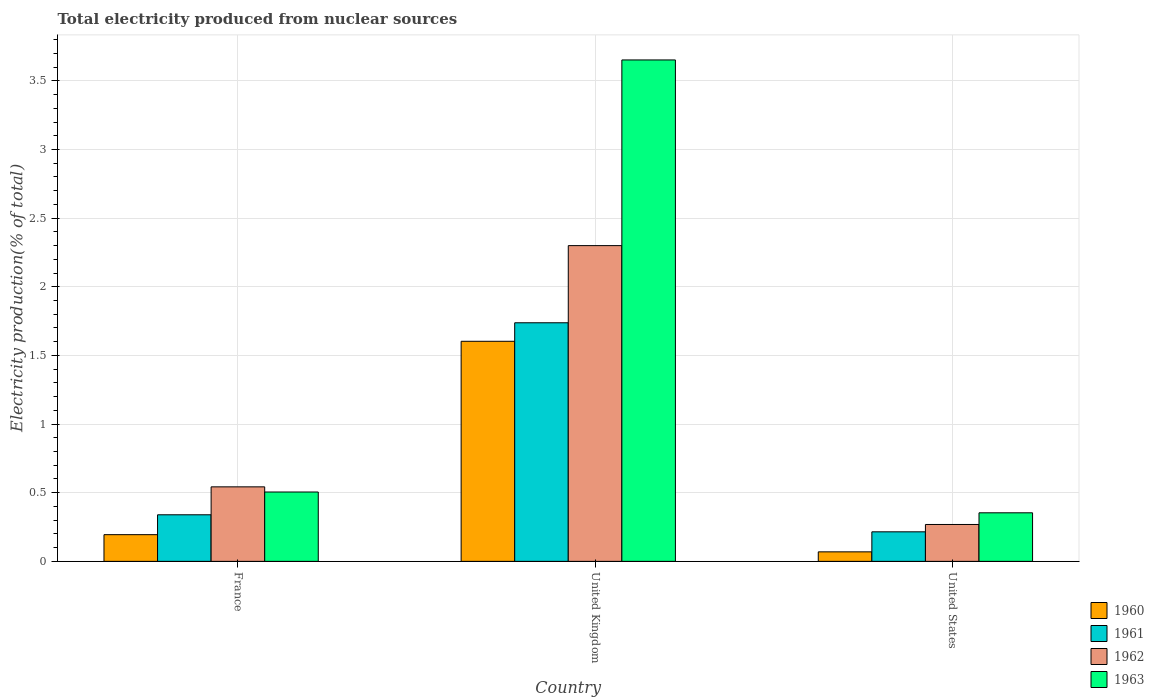How many groups of bars are there?
Offer a very short reply. 3. Are the number of bars per tick equal to the number of legend labels?
Make the answer very short. Yes. In how many cases, is the number of bars for a given country not equal to the number of legend labels?
Provide a short and direct response. 0. What is the total electricity produced in 1963 in United States?
Ensure brevity in your answer.  0.35. Across all countries, what is the maximum total electricity produced in 1963?
Ensure brevity in your answer.  3.65. Across all countries, what is the minimum total electricity produced in 1963?
Offer a terse response. 0.35. In which country was the total electricity produced in 1960 maximum?
Offer a very short reply. United Kingdom. What is the total total electricity produced in 1961 in the graph?
Your answer should be very brief. 2.29. What is the difference between the total electricity produced in 1962 in France and that in United Kingdom?
Your response must be concise. -1.76. What is the difference between the total electricity produced in 1962 in United Kingdom and the total electricity produced in 1963 in United States?
Your answer should be very brief. 1.95. What is the average total electricity produced in 1961 per country?
Provide a succinct answer. 0.76. What is the difference between the total electricity produced of/in 1961 and total electricity produced of/in 1963 in France?
Offer a very short reply. -0.17. In how many countries, is the total electricity produced in 1962 greater than 1.4 %?
Give a very brief answer. 1. What is the ratio of the total electricity produced in 1961 in United Kingdom to that in United States?
Offer a very short reply. 8.08. Is the difference between the total electricity produced in 1961 in France and United Kingdom greater than the difference between the total electricity produced in 1963 in France and United Kingdom?
Make the answer very short. Yes. What is the difference between the highest and the second highest total electricity produced in 1960?
Offer a terse response. -1.41. What is the difference between the highest and the lowest total electricity produced in 1962?
Your answer should be compact. 2.03. In how many countries, is the total electricity produced in 1960 greater than the average total electricity produced in 1960 taken over all countries?
Your answer should be compact. 1. Is the sum of the total electricity produced in 1962 in France and United States greater than the maximum total electricity produced in 1963 across all countries?
Keep it short and to the point. No. Is it the case that in every country, the sum of the total electricity produced in 1960 and total electricity produced in 1962 is greater than the sum of total electricity produced in 1961 and total electricity produced in 1963?
Offer a very short reply. No. Is it the case that in every country, the sum of the total electricity produced in 1961 and total electricity produced in 1963 is greater than the total electricity produced in 1960?
Give a very brief answer. Yes. How many bars are there?
Keep it short and to the point. 12. How many countries are there in the graph?
Your answer should be compact. 3. Where does the legend appear in the graph?
Offer a terse response. Bottom right. How many legend labels are there?
Keep it short and to the point. 4. What is the title of the graph?
Provide a short and direct response. Total electricity produced from nuclear sources. What is the label or title of the X-axis?
Provide a succinct answer. Country. What is the label or title of the Y-axis?
Make the answer very short. Electricity production(% of total). What is the Electricity production(% of total) in 1960 in France?
Ensure brevity in your answer.  0.19. What is the Electricity production(% of total) in 1961 in France?
Offer a very short reply. 0.34. What is the Electricity production(% of total) in 1962 in France?
Ensure brevity in your answer.  0.54. What is the Electricity production(% of total) in 1963 in France?
Provide a succinct answer. 0.51. What is the Electricity production(% of total) of 1960 in United Kingdom?
Your answer should be very brief. 1.6. What is the Electricity production(% of total) of 1961 in United Kingdom?
Your response must be concise. 1.74. What is the Electricity production(% of total) of 1962 in United Kingdom?
Provide a succinct answer. 2.3. What is the Electricity production(% of total) in 1963 in United Kingdom?
Provide a succinct answer. 3.65. What is the Electricity production(% of total) in 1960 in United States?
Make the answer very short. 0.07. What is the Electricity production(% of total) in 1961 in United States?
Offer a terse response. 0.22. What is the Electricity production(% of total) in 1962 in United States?
Offer a terse response. 0.27. What is the Electricity production(% of total) in 1963 in United States?
Ensure brevity in your answer.  0.35. Across all countries, what is the maximum Electricity production(% of total) in 1960?
Give a very brief answer. 1.6. Across all countries, what is the maximum Electricity production(% of total) in 1961?
Offer a very short reply. 1.74. Across all countries, what is the maximum Electricity production(% of total) of 1962?
Make the answer very short. 2.3. Across all countries, what is the maximum Electricity production(% of total) in 1963?
Provide a short and direct response. 3.65. Across all countries, what is the minimum Electricity production(% of total) in 1960?
Your answer should be very brief. 0.07. Across all countries, what is the minimum Electricity production(% of total) in 1961?
Offer a terse response. 0.22. Across all countries, what is the minimum Electricity production(% of total) in 1962?
Offer a very short reply. 0.27. Across all countries, what is the minimum Electricity production(% of total) of 1963?
Your response must be concise. 0.35. What is the total Electricity production(% of total) in 1960 in the graph?
Make the answer very short. 1.87. What is the total Electricity production(% of total) in 1961 in the graph?
Make the answer very short. 2.29. What is the total Electricity production(% of total) in 1962 in the graph?
Ensure brevity in your answer.  3.11. What is the total Electricity production(% of total) in 1963 in the graph?
Keep it short and to the point. 4.51. What is the difference between the Electricity production(% of total) of 1960 in France and that in United Kingdom?
Give a very brief answer. -1.41. What is the difference between the Electricity production(% of total) in 1961 in France and that in United Kingdom?
Ensure brevity in your answer.  -1.4. What is the difference between the Electricity production(% of total) in 1962 in France and that in United Kingdom?
Provide a short and direct response. -1.76. What is the difference between the Electricity production(% of total) of 1963 in France and that in United Kingdom?
Provide a succinct answer. -3.15. What is the difference between the Electricity production(% of total) of 1960 in France and that in United States?
Your answer should be compact. 0.13. What is the difference between the Electricity production(% of total) in 1961 in France and that in United States?
Your answer should be compact. 0.12. What is the difference between the Electricity production(% of total) of 1962 in France and that in United States?
Offer a terse response. 0.27. What is the difference between the Electricity production(% of total) of 1963 in France and that in United States?
Give a very brief answer. 0.15. What is the difference between the Electricity production(% of total) in 1960 in United Kingdom and that in United States?
Your answer should be compact. 1.53. What is the difference between the Electricity production(% of total) of 1961 in United Kingdom and that in United States?
Your response must be concise. 1.52. What is the difference between the Electricity production(% of total) of 1962 in United Kingdom and that in United States?
Give a very brief answer. 2.03. What is the difference between the Electricity production(% of total) in 1963 in United Kingdom and that in United States?
Your answer should be very brief. 3.3. What is the difference between the Electricity production(% of total) of 1960 in France and the Electricity production(% of total) of 1961 in United Kingdom?
Your response must be concise. -1.54. What is the difference between the Electricity production(% of total) of 1960 in France and the Electricity production(% of total) of 1962 in United Kingdom?
Give a very brief answer. -2.11. What is the difference between the Electricity production(% of total) of 1960 in France and the Electricity production(% of total) of 1963 in United Kingdom?
Offer a terse response. -3.46. What is the difference between the Electricity production(% of total) of 1961 in France and the Electricity production(% of total) of 1962 in United Kingdom?
Offer a terse response. -1.96. What is the difference between the Electricity production(% of total) of 1961 in France and the Electricity production(% of total) of 1963 in United Kingdom?
Your answer should be compact. -3.31. What is the difference between the Electricity production(% of total) in 1962 in France and the Electricity production(% of total) in 1963 in United Kingdom?
Your response must be concise. -3.11. What is the difference between the Electricity production(% of total) of 1960 in France and the Electricity production(% of total) of 1961 in United States?
Provide a succinct answer. -0.02. What is the difference between the Electricity production(% of total) of 1960 in France and the Electricity production(% of total) of 1962 in United States?
Your answer should be compact. -0.07. What is the difference between the Electricity production(% of total) in 1960 in France and the Electricity production(% of total) in 1963 in United States?
Your answer should be compact. -0.16. What is the difference between the Electricity production(% of total) in 1961 in France and the Electricity production(% of total) in 1962 in United States?
Ensure brevity in your answer.  0.07. What is the difference between the Electricity production(% of total) in 1961 in France and the Electricity production(% of total) in 1963 in United States?
Offer a very short reply. -0.01. What is the difference between the Electricity production(% of total) of 1962 in France and the Electricity production(% of total) of 1963 in United States?
Your answer should be compact. 0.19. What is the difference between the Electricity production(% of total) in 1960 in United Kingdom and the Electricity production(% of total) in 1961 in United States?
Offer a very short reply. 1.39. What is the difference between the Electricity production(% of total) of 1960 in United Kingdom and the Electricity production(% of total) of 1962 in United States?
Give a very brief answer. 1.33. What is the difference between the Electricity production(% of total) of 1960 in United Kingdom and the Electricity production(% of total) of 1963 in United States?
Your answer should be very brief. 1.25. What is the difference between the Electricity production(% of total) of 1961 in United Kingdom and the Electricity production(% of total) of 1962 in United States?
Keep it short and to the point. 1.47. What is the difference between the Electricity production(% of total) in 1961 in United Kingdom and the Electricity production(% of total) in 1963 in United States?
Offer a very short reply. 1.38. What is the difference between the Electricity production(% of total) of 1962 in United Kingdom and the Electricity production(% of total) of 1963 in United States?
Keep it short and to the point. 1.95. What is the average Electricity production(% of total) of 1960 per country?
Your response must be concise. 0.62. What is the average Electricity production(% of total) of 1961 per country?
Offer a very short reply. 0.76. What is the average Electricity production(% of total) of 1963 per country?
Your response must be concise. 1.5. What is the difference between the Electricity production(% of total) in 1960 and Electricity production(% of total) in 1961 in France?
Keep it short and to the point. -0.14. What is the difference between the Electricity production(% of total) in 1960 and Electricity production(% of total) in 1962 in France?
Provide a short and direct response. -0.35. What is the difference between the Electricity production(% of total) in 1960 and Electricity production(% of total) in 1963 in France?
Ensure brevity in your answer.  -0.31. What is the difference between the Electricity production(% of total) in 1961 and Electricity production(% of total) in 1962 in France?
Your answer should be very brief. -0.2. What is the difference between the Electricity production(% of total) of 1961 and Electricity production(% of total) of 1963 in France?
Offer a very short reply. -0.17. What is the difference between the Electricity production(% of total) of 1962 and Electricity production(% of total) of 1963 in France?
Your answer should be very brief. 0.04. What is the difference between the Electricity production(% of total) in 1960 and Electricity production(% of total) in 1961 in United Kingdom?
Your answer should be compact. -0.13. What is the difference between the Electricity production(% of total) in 1960 and Electricity production(% of total) in 1962 in United Kingdom?
Provide a short and direct response. -0.7. What is the difference between the Electricity production(% of total) of 1960 and Electricity production(% of total) of 1963 in United Kingdom?
Keep it short and to the point. -2.05. What is the difference between the Electricity production(% of total) in 1961 and Electricity production(% of total) in 1962 in United Kingdom?
Keep it short and to the point. -0.56. What is the difference between the Electricity production(% of total) of 1961 and Electricity production(% of total) of 1963 in United Kingdom?
Make the answer very short. -1.91. What is the difference between the Electricity production(% of total) in 1962 and Electricity production(% of total) in 1963 in United Kingdom?
Offer a very short reply. -1.35. What is the difference between the Electricity production(% of total) of 1960 and Electricity production(% of total) of 1961 in United States?
Keep it short and to the point. -0.15. What is the difference between the Electricity production(% of total) in 1960 and Electricity production(% of total) in 1962 in United States?
Keep it short and to the point. -0.2. What is the difference between the Electricity production(% of total) of 1960 and Electricity production(% of total) of 1963 in United States?
Give a very brief answer. -0.28. What is the difference between the Electricity production(% of total) of 1961 and Electricity production(% of total) of 1962 in United States?
Your answer should be very brief. -0.05. What is the difference between the Electricity production(% of total) of 1961 and Electricity production(% of total) of 1963 in United States?
Keep it short and to the point. -0.14. What is the difference between the Electricity production(% of total) in 1962 and Electricity production(% of total) in 1963 in United States?
Make the answer very short. -0.09. What is the ratio of the Electricity production(% of total) of 1960 in France to that in United Kingdom?
Your answer should be compact. 0.12. What is the ratio of the Electricity production(% of total) in 1961 in France to that in United Kingdom?
Provide a short and direct response. 0.2. What is the ratio of the Electricity production(% of total) of 1962 in France to that in United Kingdom?
Ensure brevity in your answer.  0.24. What is the ratio of the Electricity production(% of total) in 1963 in France to that in United Kingdom?
Ensure brevity in your answer.  0.14. What is the ratio of the Electricity production(% of total) in 1960 in France to that in United States?
Give a very brief answer. 2.81. What is the ratio of the Electricity production(% of total) of 1961 in France to that in United States?
Offer a very short reply. 1.58. What is the ratio of the Electricity production(% of total) of 1962 in France to that in United States?
Make the answer very short. 2.02. What is the ratio of the Electricity production(% of total) of 1963 in France to that in United States?
Provide a succinct answer. 1.43. What is the ratio of the Electricity production(% of total) in 1960 in United Kingdom to that in United States?
Make the answer very short. 23.14. What is the ratio of the Electricity production(% of total) in 1961 in United Kingdom to that in United States?
Provide a short and direct response. 8.08. What is the ratio of the Electricity production(% of total) of 1962 in United Kingdom to that in United States?
Keep it short and to the point. 8.56. What is the ratio of the Electricity production(% of total) in 1963 in United Kingdom to that in United States?
Keep it short and to the point. 10.32. What is the difference between the highest and the second highest Electricity production(% of total) in 1960?
Offer a very short reply. 1.41. What is the difference between the highest and the second highest Electricity production(% of total) of 1961?
Ensure brevity in your answer.  1.4. What is the difference between the highest and the second highest Electricity production(% of total) in 1962?
Make the answer very short. 1.76. What is the difference between the highest and the second highest Electricity production(% of total) of 1963?
Ensure brevity in your answer.  3.15. What is the difference between the highest and the lowest Electricity production(% of total) in 1960?
Ensure brevity in your answer.  1.53. What is the difference between the highest and the lowest Electricity production(% of total) in 1961?
Your answer should be compact. 1.52. What is the difference between the highest and the lowest Electricity production(% of total) of 1962?
Your answer should be compact. 2.03. What is the difference between the highest and the lowest Electricity production(% of total) in 1963?
Make the answer very short. 3.3. 